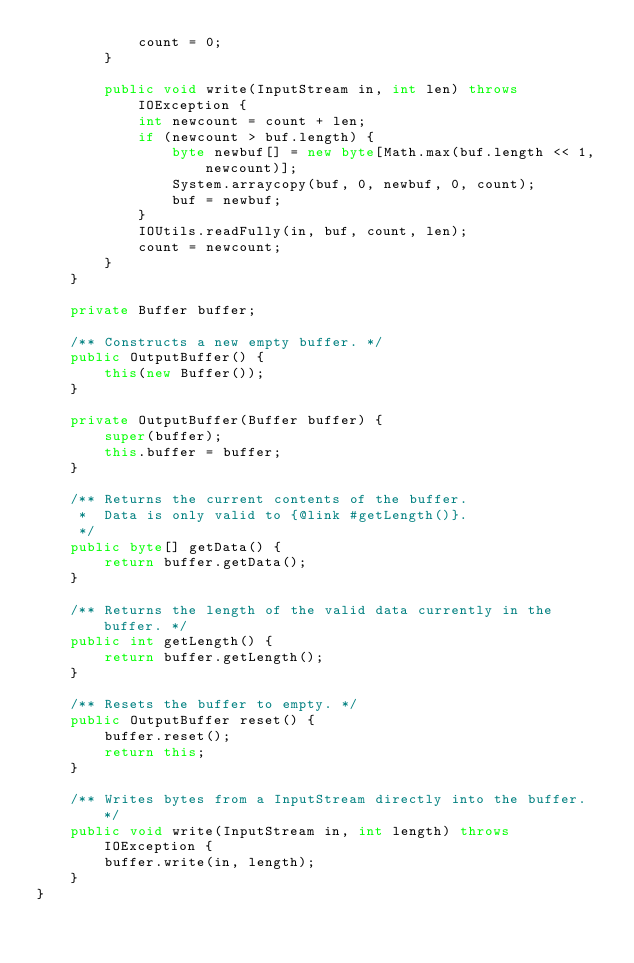<code> <loc_0><loc_0><loc_500><loc_500><_Java_>            count = 0;
        }

        public void write(InputStream in, int len) throws IOException {
            int newcount = count + len;
            if (newcount > buf.length) {
                byte newbuf[] = new byte[Math.max(buf.length << 1, newcount)];
                System.arraycopy(buf, 0, newbuf, 0, count);
                buf = newbuf;
            }
            IOUtils.readFully(in, buf, count, len);
            count = newcount;
        }
    }

    private Buffer buffer;

    /** Constructs a new empty buffer. */
    public OutputBuffer() {
        this(new Buffer());
    }

    private OutputBuffer(Buffer buffer) {
        super(buffer);
        this.buffer = buffer;
    }

    /** Returns the current contents of the buffer.
     *  Data is only valid to {@link #getLength()}.
     */
    public byte[] getData() {
        return buffer.getData();
    }

    /** Returns the length of the valid data currently in the buffer. */
    public int getLength() {
        return buffer.getLength();
    }

    /** Resets the buffer to empty. */
    public OutputBuffer reset() {
        buffer.reset();
        return this;
    }

    /** Writes bytes from a InputStream directly into the buffer. */
    public void write(InputStream in, int length) throws IOException {
        buffer.write(in, length);
    }
}
</code> 